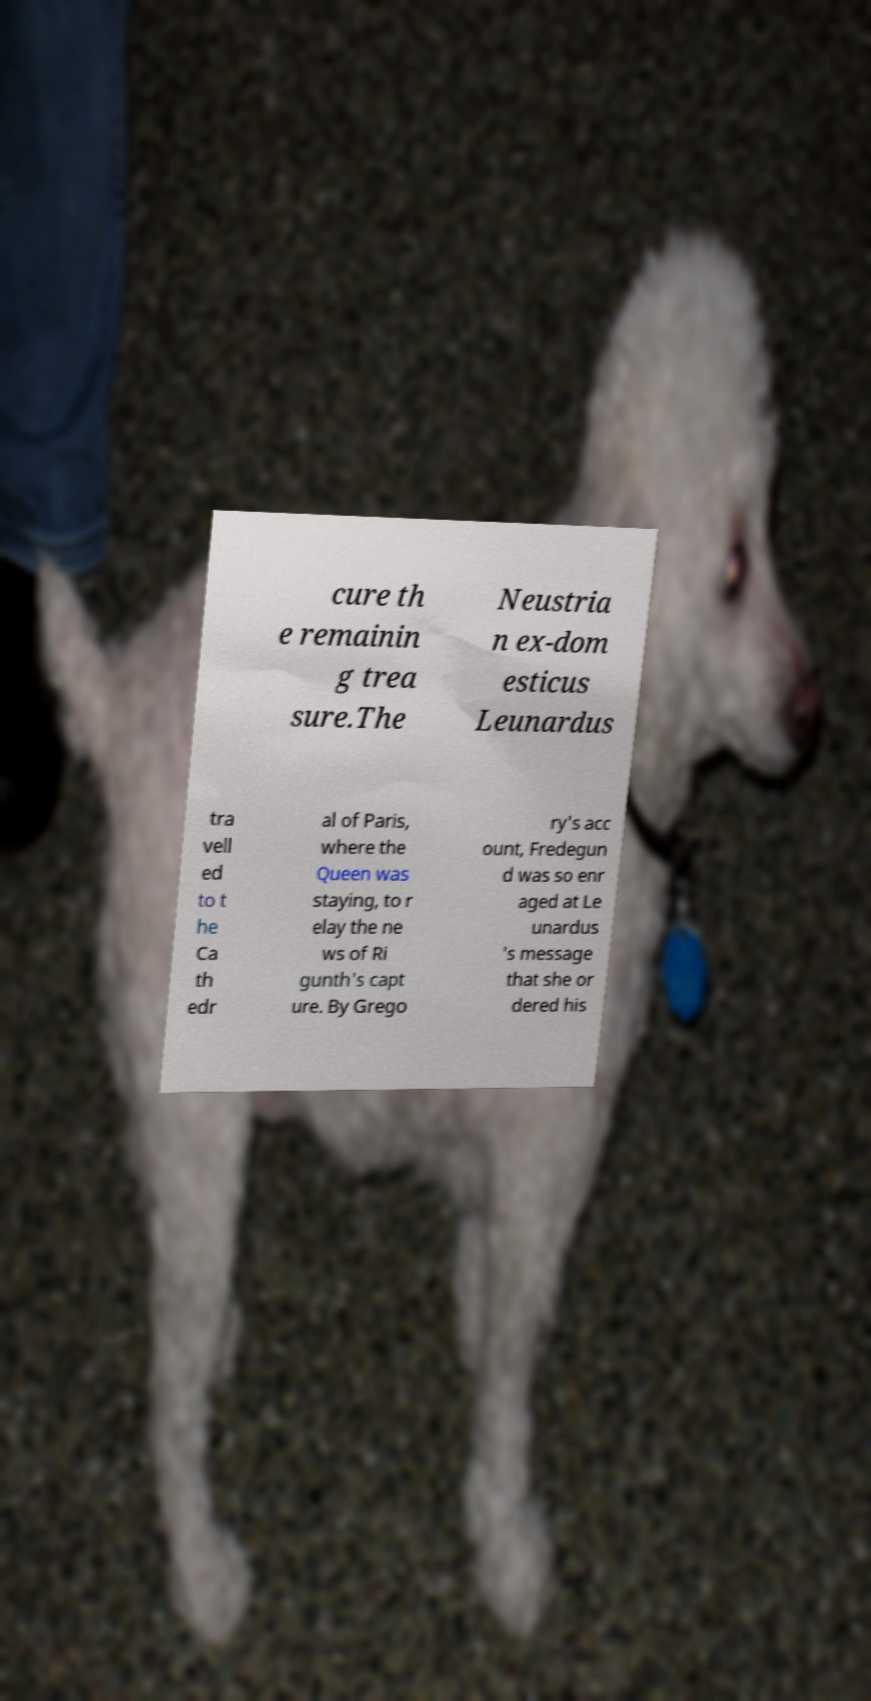Can you read and provide the text displayed in the image?This photo seems to have some interesting text. Can you extract and type it out for me? cure th e remainin g trea sure.The Neustria n ex-dom esticus Leunardus tra vell ed to t he Ca th edr al of Paris, where the Queen was staying, to r elay the ne ws of Ri gunth's capt ure. By Grego ry's acc ount, Fredegun d was so enr aged at Le unardus 's message that she or dered his 